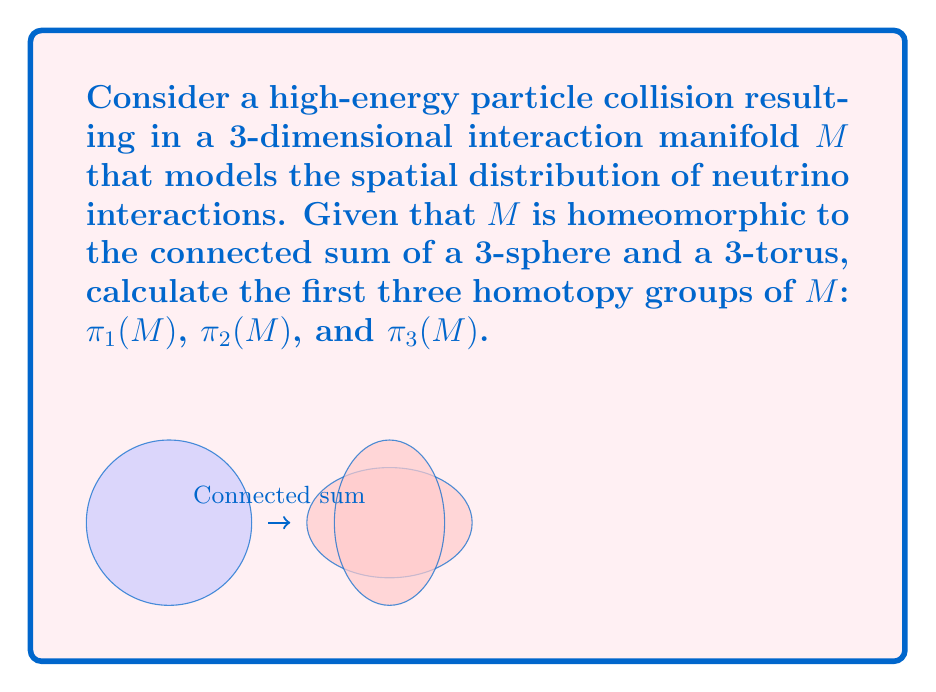Can you answer this question? To solve this problem, we'll follow these steps:

1) First, recall that $M$ is homeomorphic to $S^3 \# T^3$, where $S^3$ is a 3-sphere and $T^3$ is a 3-torus.

2) For the fundamental group $\pi_1(M)$:
   - $\pi_1(S^3) = 0$ (3-sphere is simply connected)
   - $\pi_1(T^3) \cong \mathbb{Z} \oplus \mathbb{Z} \oplus \mathbb{Z}$
   - For connected sums, $\pi_1(A \# B) \cong \pi_1(A) * \pi_1(B)$
   Therefore, $\pi_1(M) \cong \pi_1(S^3) * \pi_1(T^3) \cong 0 * (\mathbb{Z} \oplus \mathbb{Z} \oplus \mathbb{Z}) \cong \mathbb{Z} \oplus \mathbb{Z} \oplus \mathbb{Z}$

3) For $\pi_2(M)$:
   - $\pi_2(S^3) = 0$
   - $\pi_2(T^3) = 0$
   - The 2nd homotopy group of a connected sum is the direct sum of the 2nd homotopy groups
   Therefore, $\pi_2(M) \cong \pi_2(S^3) \oplus \pi_2(T^3) \cong 0 \oplus 0 \cong 0$

4) For $\pi_3(M)$:
   - $\pi_3(S^3) \cong \mathbb{Z}$ (by definition of the 3-sphere)
   - $\pi_3(T^3) \cong \pi_3(S^1 \times S^1 \times S^1) \cong \pi_3(S^1) \oplus \pi_3(S^1) \oplus \pi_3(S^1) \cong 0$
   - For higher homotopy groups ($n \geq 2$), $\pi_n(A \# B) \cong \pi_n(A) \oplus \pi_n(B)$
   Therefore, $\pi_3(M) \cong \pi_3(S^3) \oplus \pi_3(T^3) \cong \mathbb{Z} \oplus 0 \cong \mathbb{Z}$
Answer: $\pi_1(M) \cong \mathbb{Z}^3$, $\pi_2(M) \cong 0$, $\pi_3(M) \cong \mathbb{Z}$ 